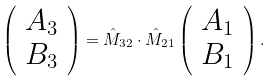<formula> <loc_0><loc_0><loc_500><loc_500>\left ( \begin{array} { c } A _ { 3 } \\ B _ { 3 } \end{array} \right ) = \hat { M } _ { 3 2 } \cdot \hat { M } _ { 2 1 } \left ( \begin{array} { c } A _ { 1 } \\ B _ { 1 } \end{array} \right ) .</formula> 